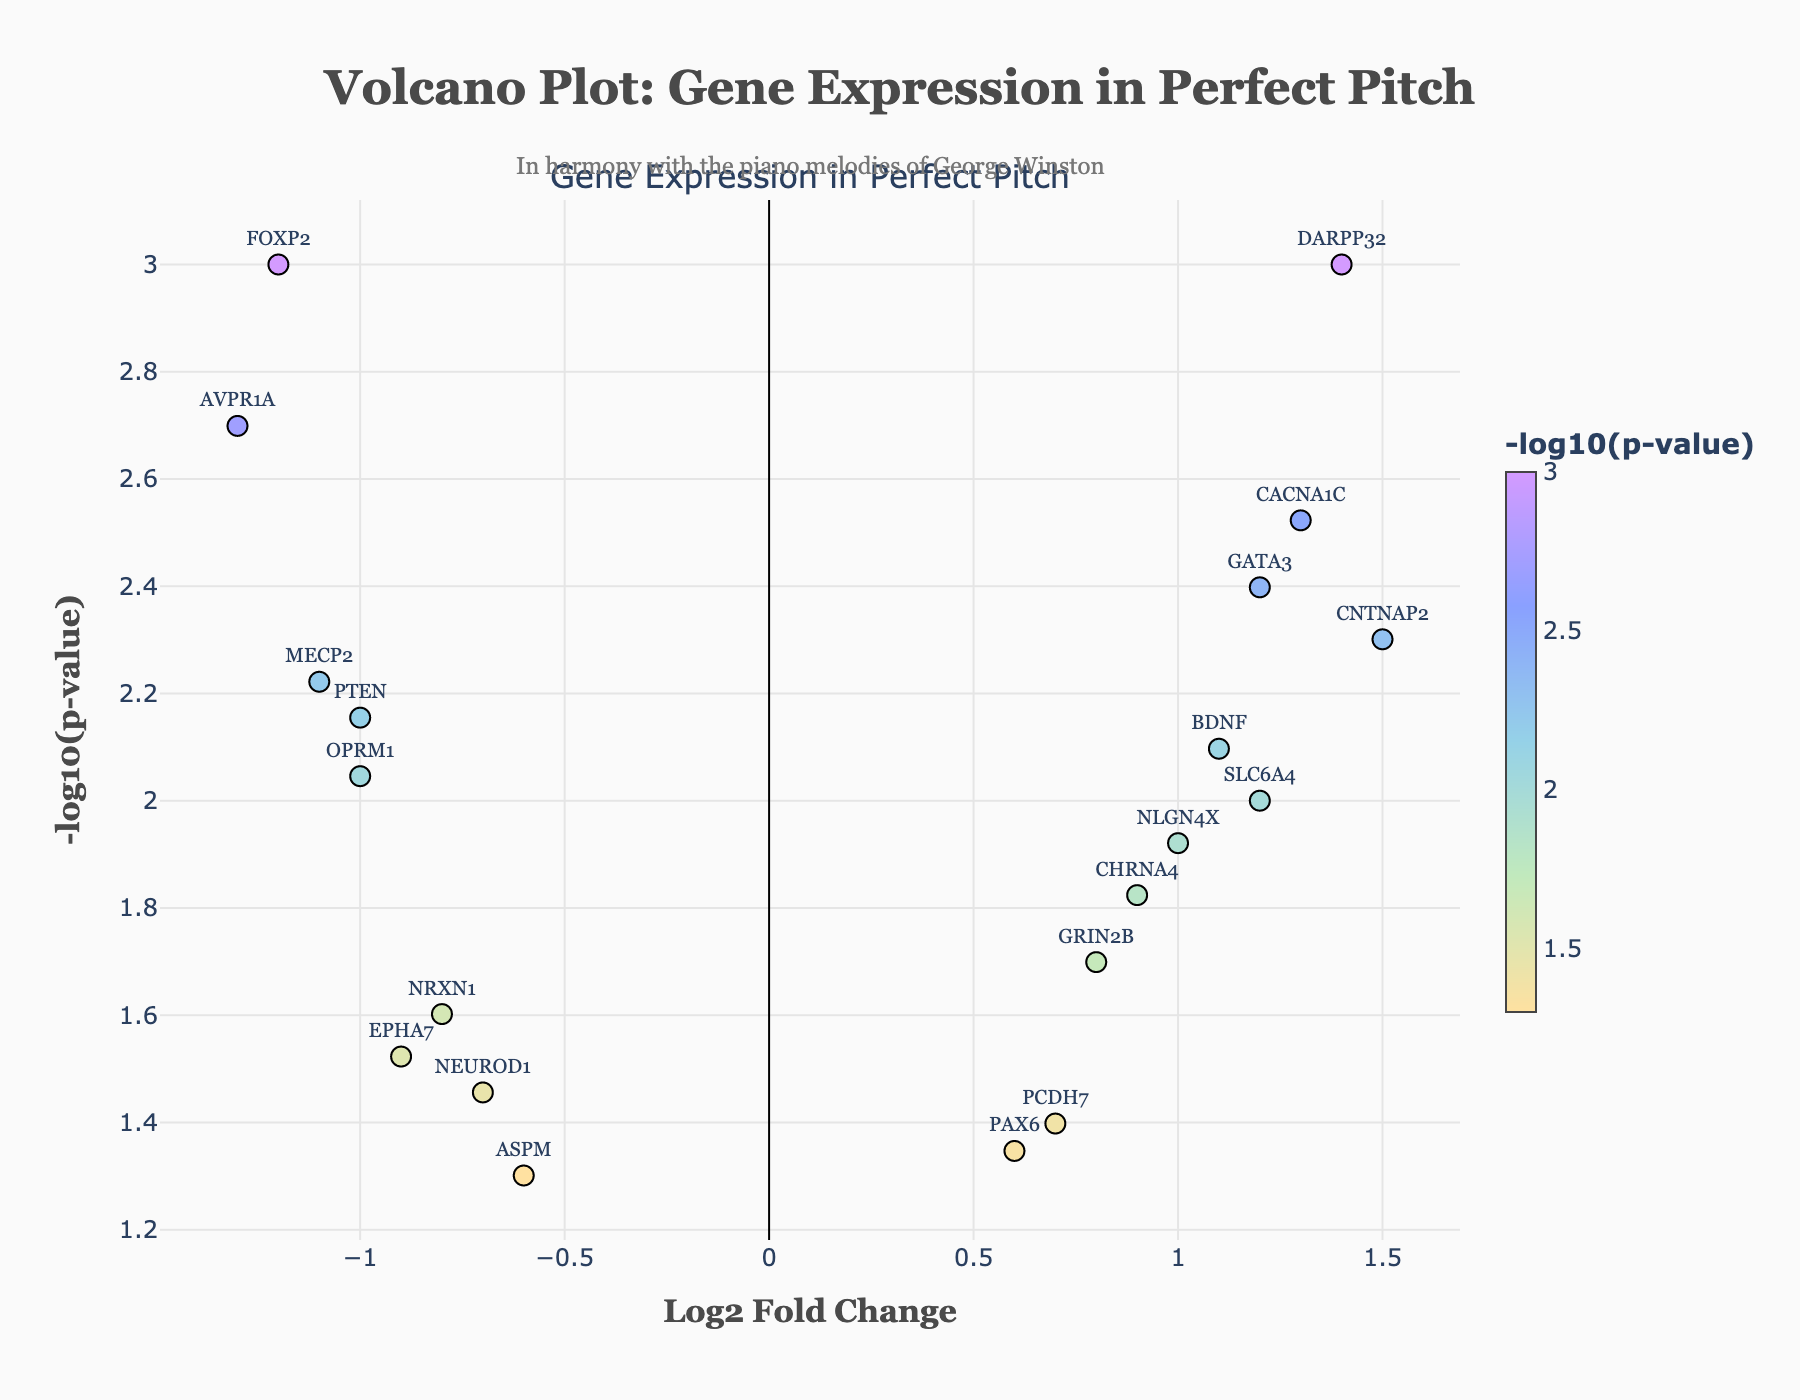What's the overall title of the plot? The overall title of the plot is displayed at the top and reads "<b>Volcano Plot: Gene Expression in Perfect Pitch</b>". This title provides the context of the figure.
Answer: Volcano Plot: Gene Expression in Perfect Pitch What do the x-axis and y-axis represent? The x-axis represents the "Log2 Fold Change," which indicates the change in gene expression levels, while the y-axis represents the "-log10(p-value)," which indicates the significance of the change. These axes help in interpreting the gene expression and its significance.
Answer: Log2 Fold Change, -log10(p-value) How many genes have a negative log2 fold change? Count the data points on the left side of the vertical axis (where Log2 Fold Change is negative). These include FOXP2, EPHA7, AVPR1A, ASPM, PTEN, NRXN1, MECP2, NEUROD1, and OPRM1, making it a total of 9 genes.
Answer: 9 Which gene has the highest log2 fold change? Locate the data point farthest to the right on the x-axis. Here, CNTNAP2 with a log2 fold change of 1.5 is the farthest right.
Answer: CNTNAP2 Which gene has the most significant p-value? The most significant p-value is represented by the highest -log10(p-value). DARPP32, positioned highest on the y-axis, has this value, indicating it has the most significant p-value.
Answer: DARPP32 What is the log2 fold change for the gene BDNF? Find the data point labeled "BDNF" and look at its position on the x-axis. BDNF is positioned at approximately 1.1 on the Log2 Fold Change scale.
Answer: 1.1 Compare the log2 fold changes of FOXP2 and CHRNA4. Which one is greater? FOXP2 has a log2 fold change of -1.2, and CHRNA4 has a log2 fold change of 0.9. Comparing these values, 0.9 is greater than -1.2.
Answer: CHRNA4 Is the gene with the lowest log2 fold change also the one with the most significant p-value? The gene with the lowest log2 fold change (most negative) is AVPR1A with -1.3. The gene with the most significant p-value (highest -log10(p-value)) is DARPP32. Since they are different genes, the answer is no.
Answer: No 